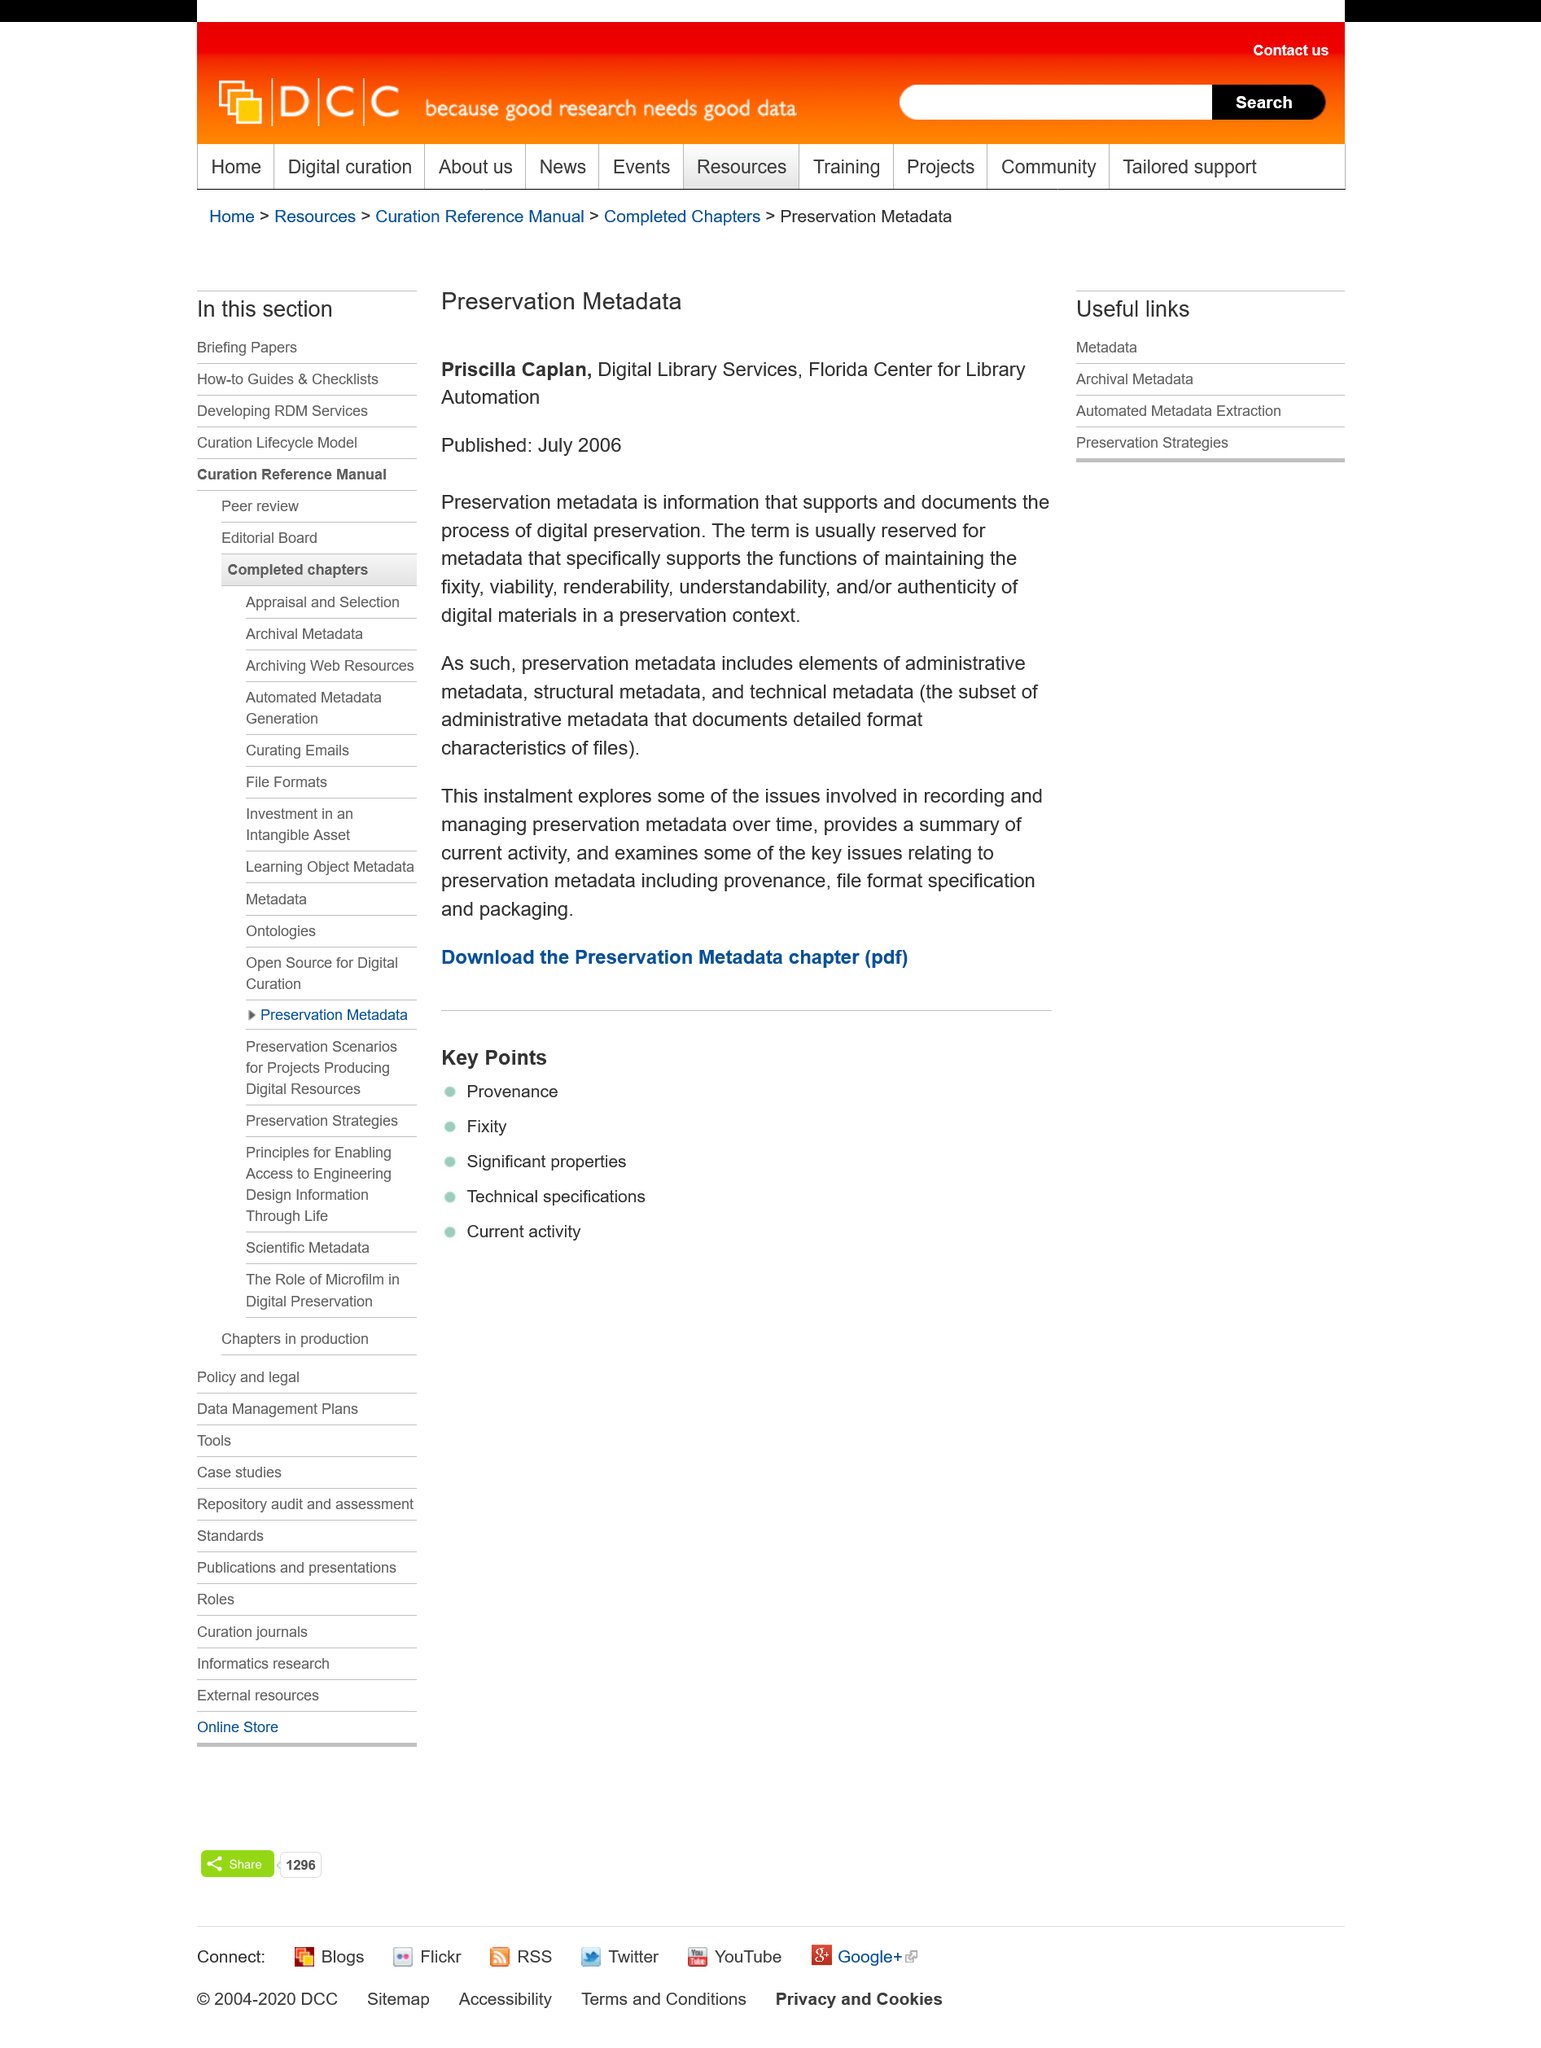Mention a couple of crucial points in this snapshot. The content was published on July 2006. Digital preservation metadata is information that is used to support and document the process of preserving digital assets. Preservation metadata includes elements such as administrative metadata, structural metadata, and technical metadata that are used to describe and manage digital content for long-term preservation purposes. 